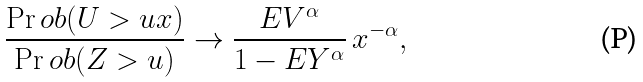<formula> <loc_0><loc_0><loc_500><loc_500>\frac { \Pr o b ( U > u x ) } { \Pr o b ( Z > u ) } \to \frac { E V ^ { \alpha } } { 1 - E Y ^ { \alpha } } \, x ^ { - \alpha } ,</formula> 